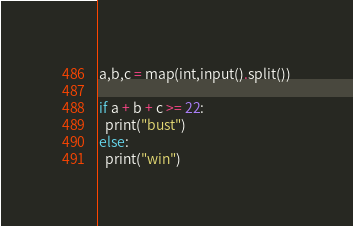<code> <loc_0><loc_0><loc_500><loc_500><_Python_>a,b,c = map(int,input().split())

if a + b + c >= 22:
  print("bust")
else:
  print("win")</code> 